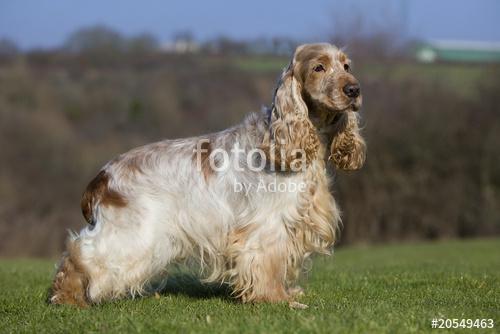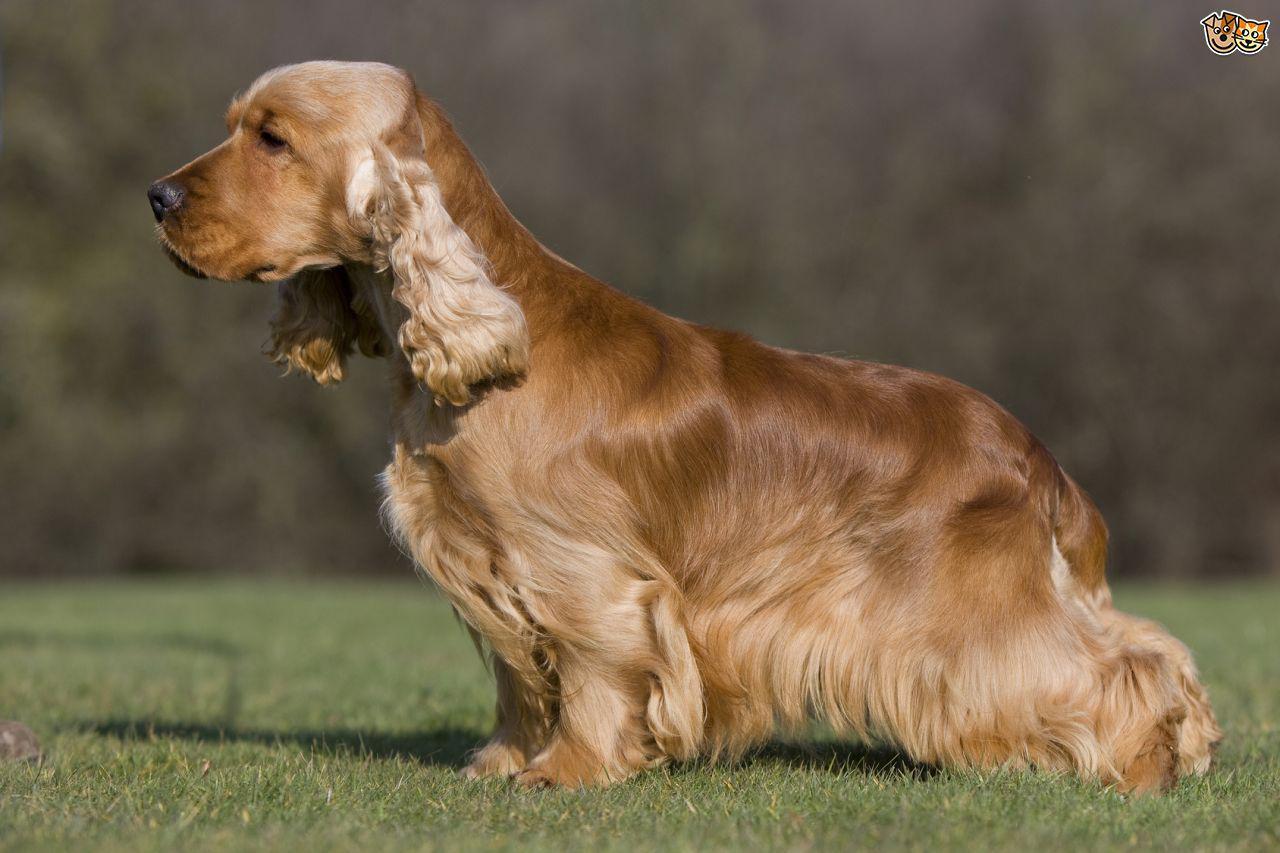The first image is the image on the left, the second image is the image on the right. For the images shown, is this caption "The sky can be seen in the background of one of the images." true? Answer yes or no. Yes. The first image is the image on the left, the second image is the image on the right. Examine the images to the left and right. Is the description "A total of two dogs are shown, with none of them standing." accurate? Answer yes or no. No. 